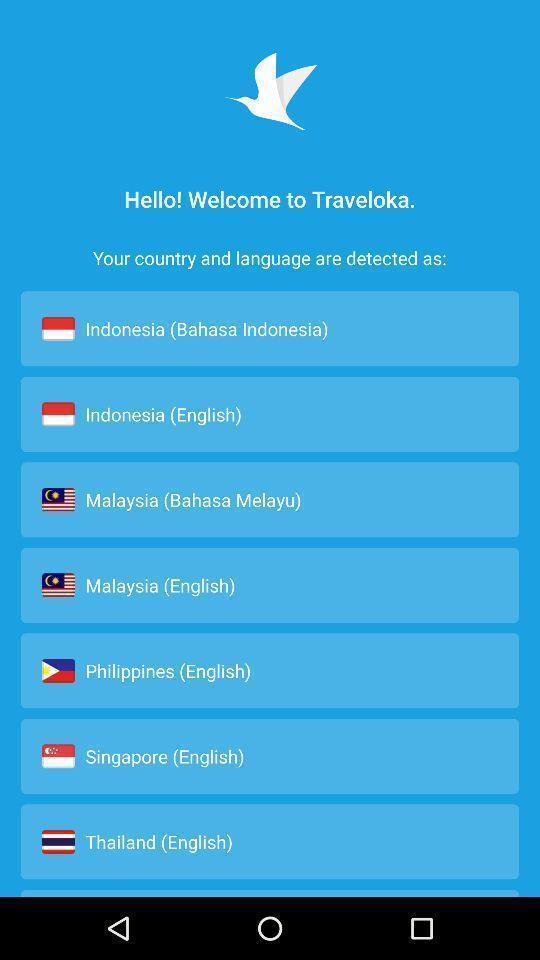Give me a summary of this screen capture. Welcome page of social app. 